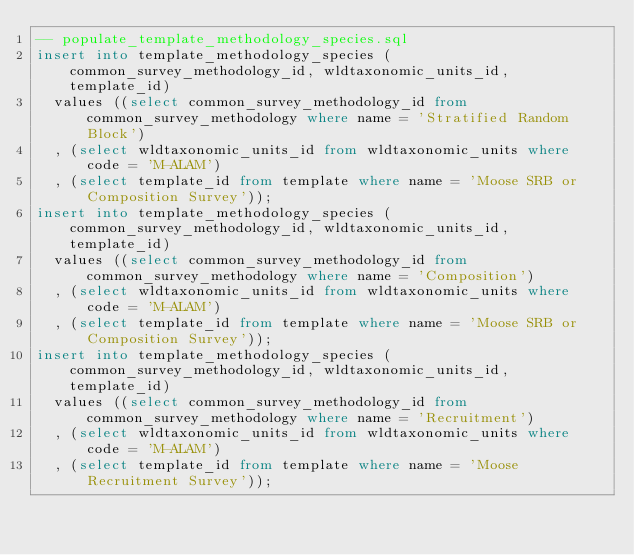Convert code to text. <code><loc_0><loc_0><loc_500><loc_500><_SQL_>-- populate_template_methodology_species.sql
insert into template_methodology_species (common_survey_methodology_id, wldtaxonomic_units_id, template_id)
  values ((select common_survey_methodology_id from common_survey_methodology where name = 'Stratified Random Block')
  , (select wldtaxonomic_units_id from wldtaxonomic_units where code = 'M-ALAM')
  , (select template_id from template where name = 'Moose SRB or Composition Survey'));
insert into template_methodology_species (common_survey_methodology_id, wldtaxonomic_units_id, template_id)
  values ((select common_survey_methodology_id from common_survey_methodology where name = 'Composition')
  , (select wldtaxonomic_units_id from wldtaxonomic_units where code = 'M-ALAM')
  , (select template_id from template where name = 'Moose SRB or Composition Survey'));
insert into template_methodology_species (common_survey_methodology_id, wldtaxonomic_units_id, template_id)
  values ((select common_survey_methodology_id from common_survey_methodology where name = 'Recruitment')
  , (select wldtaxonomic_units_id from wldtaxonomic_units where code = 'M-ALAM')
  , (select template_id from template where name = 'Moose Recruitment Survey'));
</code> 